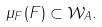<formula> <loc_0><loc_0><loc_500><loc_500>\mu _ { F } ( F ) \subset \mathcal { W } _ { A } .</formula> 